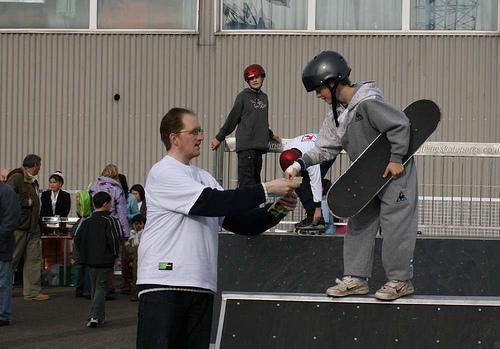How many helmets are there?
Give a very brief answer. 3. How many people are wearing helmets?
Give a very brief answer. 3. How many people are visible?
Give a very brief answer. 5. 